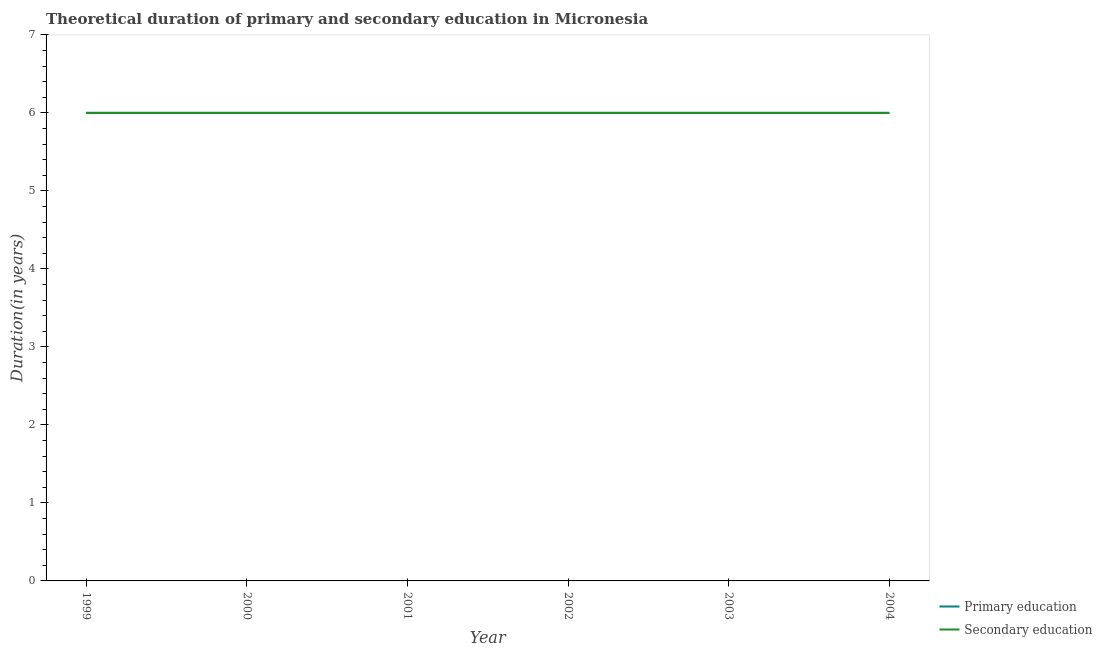What is the duration of secondary education in 2000?
Your answer should be very brief. 6. Across all years, what is the maximum duration of primary education?
Offer a very short reply. 6. Across all years, what is the minimum duration of secondary education?
Make the answer very short. 6. What is the total duration of secondary education in the graph?
Offer a terse response. 36. What is the difference between the duration of primary education in 2004 and the duration of secondary education in 2003?
Give a very brief answer. 0. What is the average duration of secondary education per year?
Offer a very short reply. 6. In how many years, is the duration of primary education greater than 2.8 years?
Offer a very short reply. 6. Is the difference between the duration of secondary education in 2000 and 2001 greater than the difference between the duration of primary education in 2000 and 2001?
Your answer should be compact. No. Is the sum of the duration of secondary education in 2003 and 2004 greater than the maximum duration of primary education across all years?
Offer a very short reply. Yes. Does the duration of secondary education monotonically increase over the years?
Make the answer very short. No. Is the duration of secondary education strictly greater than the duration of primary education over the years?
Keep it short and to the point. No. How many lines are there?
Give a very brief answer. 2. What is the difference between two consecutive major ticks on the Y-axis?
Keep it short and to the point. 1. Does the graph contain grids?
Make the answer very short. No. Where does the legend appear in the graph?
Provide a short and direct response. Bottom right. How many legend labels are there?
Give a very brief answer. 2. What is the title of the graph?
Offer a terse response. Theoretical duration of primary and secondary education in Micronesia. Does "Time to export" appear as one of the legend labels in the graph?
Offer a terse response. No. What is the label or title of the X-axis?
Give a very brief answer. Year. What is the label or title of the Y-axis?
Your answer should be very brief. Duration(in years). What is the Duration(in years) of Secondary education in 2000?
Keep it short and to the point. 6. What is the Duration(in years) in Secondary education in 2001?
Make the answer very short. 6. What is the Duration(in years) in Secondary education in 2002?
Provide a short and direct response. 6. What is the Duration(in years) of Primary education in 2003?
Ensure brevity in your answer.  6. What is the Duration(in years) of Secondary education in 2003?
Make the answer very short. 6. What is the Duration(in years) of Primary education in 2004?
Make the answer very short. 6. What is the Duration(in years) of Secondary education in 2004?
Provide a succinct answer. 6. Across all years, what is the maximum Duration(in years) of Primary education?
Make the answer very short. 6. Across all years, what is the maximum Duration(in years) in Secondary education?
Provide a short and direct response. 6. What is the total Duration(in years) in Primary education in the graph?
Provide a succinct answer. 36. What is the difference between the Duration(in years) in Primary education in 1999 and that in 2000?
Ensure brevity in your answer.  0. What is the difference between the Duration(in years) of Primary education in 1999 and that in 2001?
Ensure brevity in your answer.  0. What is the difference between the Duration(in years) in Secondary education in 1999 and that in 2001?
Provide a succinct answer. 0. What is the difference between the Duration(in years) of Primary education in 1999 and that in 2004?
Ensure brevity in your answer.  0. What is the difference between the Duration(in years) in Secondary education in 1999 and that in 2004?
Provide a short and direct response. 0. What is the difference between the Duration(in years) of Primary education in 2000 and that in 2002?
Keep it short and to the point. 0. What is the difference between the Duration(in years) in Primary education in 2000 and that in 2004?
Make the answer very short. 0. What is the difference between the Duration(in years) of Secondary education in 2001 and that in 2002?
Keep it short and to the point. 0. What is the difference between the Duration(in years) of Primary education in 2001 and that in 2003?
Your answer should be compact. 0. What is the difference between the Duration(in years) in Secondary education in 2001 and that in 2003?
Your response must be concise. 0. What is the difference between the Duration(in years) in Secondary education in 2001 and that in 2004?
Your response must be concise. 0. What is the difference between the Duration(in years) of Primary education in 2002 and that in 2003?
Your answer should be compact. 0. What is the difference between the Duration(in years) of Primary education in 2002 and that in 2004?
Keep it short and to the point. 0. What is the difference between the Duration(in years) in Primary education in 2003 and that in 2004?
Offer a very short reply. 0. What is the difference between the Duration(in years) of Secondary education in 2003 and that in 2004?
Offer a very short reply. 0. What is the difference between the Duration(in years) of Primary education in 1999 and the Duration(in years) of Secondary education in 2000?
Give a very brief answer. 0. What is the difference between the Duration(in years) of Primary education in 1999 and the Duration(in years) of Secondary education in 2002?
Offer a very short reply. 0. What is the difference between the Duration(in years) of Primary education in 1999 and the Duration(in years) of Secondary education in 2003?
Offer a very short reply. 0. What is the difference between the Duration(in years) in Primary education in 1999 and the Duration(in years) in Secondary education in 2004?
Your answer should be compact. 0. What is the difference between the Duration(in years) of Primary education in 2000 and the Duration(in years) of Secondary education in 2001?
Give a very brief answer. 0. What is the difference between the Duration(in years) in Primary education in 2000 and the Duration(in years) in Secondary education in 2003?
Provide a short and direct response. 0. What is the difference between the Duration(in years) in Primary education in 2001 and the Duration(in years) in Secondary education in 2002?
Ensure brevity in your answer.  0. What is the difference between the Duration(in years) in Primary education in 2001 and the Duration(in years) in Secondary education in 2003?
Offer a terse response. 0. What is the difference between the Duration(in years) of Primary education in 2002 and the Duration(in years) of Secondary education in 2003?
Make the answer very short. 0. What is the difference between the Duration(in years) in Primary education in 2002 and the Duration(in years) in Secondary education in 2004?
Provide a short and direct response. 0. What is the difference between the Duration(in years) in Primary education in 2003 and the Duration(in years) in Secondary education in 2004?
Your response must be concise. 0. What is the average Duration(in years) in Secondary education per year?
Keep it short and to the point. 6. In the year 2000, what is the difference between the Duration(in years) of Primary education and Duration(in years) of Secondary education?
Provide a short and direct response. 0. In the year 2002, what is the difference between the Duration(in years) of Primary education and Duration(in years) of Secondary education?
Give a very brief answer. 0. In the year 2003, what is the difference between the Duration(in years) in Primary education and Duration(in years) in Secondary education?
Your response must be concise. 0. What is the ratio of the Duration(in years) in Primary education in 1999 to that in 2000?
Offer a terse response. 1. What is the ratio of the Duration(in years) of Secondary education in 1999 to that in 2000?
Your answer should be very brief. 1. What is the ratio of the Duration(in years) in Primary education in 1999 to that in 2003?
Offer a terse response. 1. What is the ratio of the Duration(in years) in Secondary education in 1999 to that in 2003?
Your answer should be very brief. 1. What is the ratio of the Duration(in years) in Primary education in 1999 to that in 2004?
Provide a succinct answer. 1. What is the ratio of the Duration(in years) of Secondary education in 2000 to that in 2002?
Offer a very short reply. 1. What is the ratio of the Duration(in years) of Primary education in 2000 to that in 2003?
Make the answer very short. 1. What is the ratio of the Duration(in years) in Secondary education in 2000 to that in 2003?
Provide a succinct answer. 1. What is the ratio of the Duration(in years) of Secondary education in 2000 to that in 2004?
Your answer should be compact. 1. What is the ratio of the Duration(in years) of Secondary education in 2001 to that in 2002?
Offer a terse response. 1. What is the ratio of the Duration(in years) in Primary education in 2001 to that in 2003?
Make the answer very short. 1. What is the ratio of the Duration(in years) in Secondary education in 2001 to that in 2003?
Offer a terse response. 1. What is the ratio of the Duration(in years) of Secondary education in 2001 to that in 2004?
Make the answer very short. 1. What is the difference between the highest and the second highest Duration(in years) of Secondary education?
Your answer should be compact. 0. What is the difference between the highest and the lowest Duration(in years) of Secondary education?
Make the answer very short. 0. 